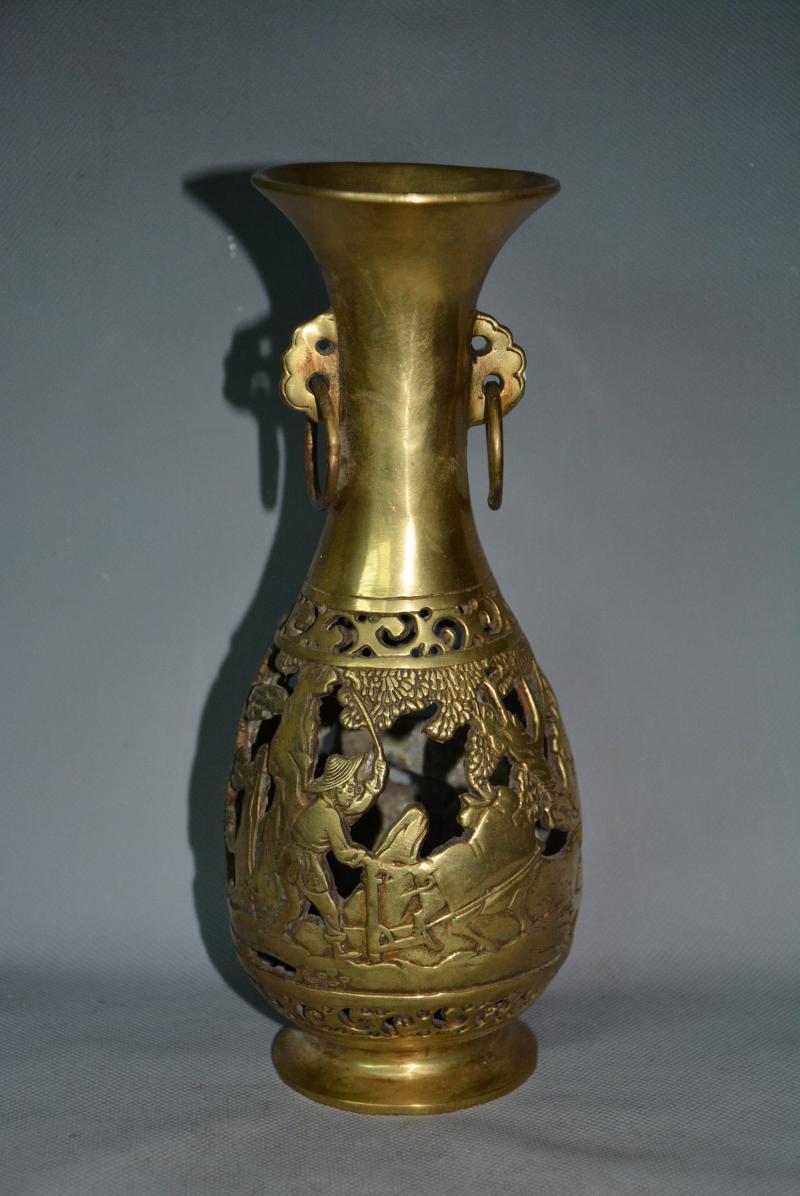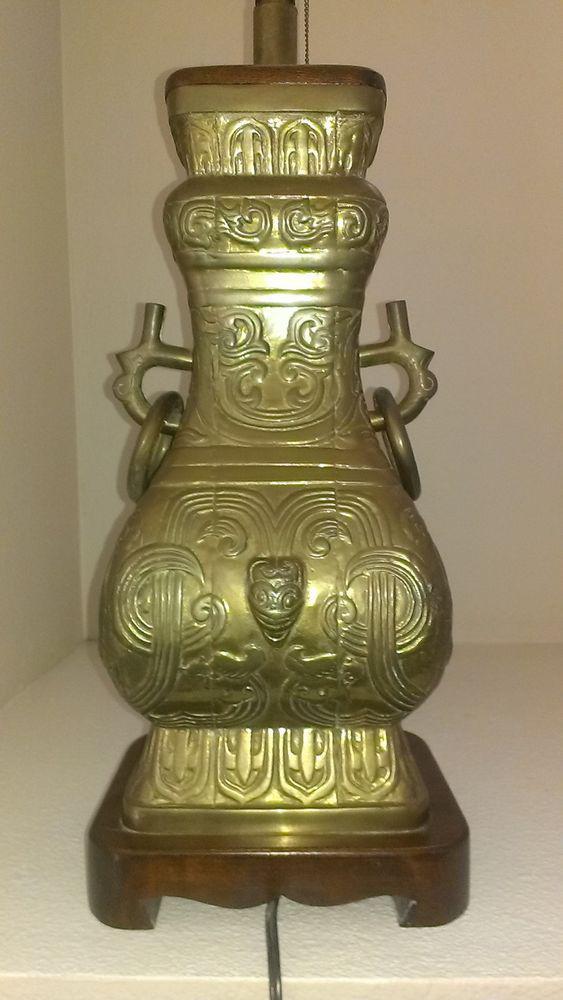The first image is the image on the left, the second image is the image on the right. Evaluate the accuracy of this statement regarding the images: "There are side handles on the vase.". Is it true? Answer yes or no. Yes. 